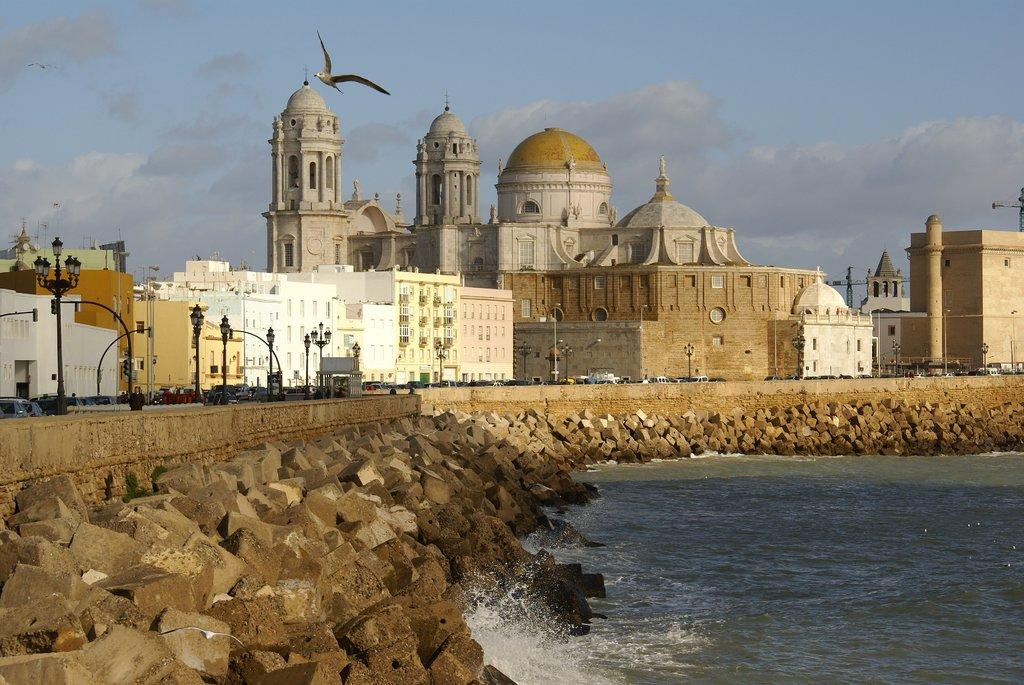What type of structures can be seen in the image? There are buildings in the image. What type of lighting is present along the road in the image? Street lights are present in the image. What is flying in the sky in the image? A bird is flying in the sky in the image. What type of transportation can be seen on the road in the image? There are vehicles on the road in the image. What natural elements are present on the right side of the image? There are stones and water on the right side of the image. How does the pollution affect the bird's flight in the image? There is no mention of pollution in the image, so we cannot determine its effect on the bird's flight. What type of cover is provided by the stones and water on the right side of the image? The stones and water on the right side of the image do not provide any cover; they are natural elements in the scene. 